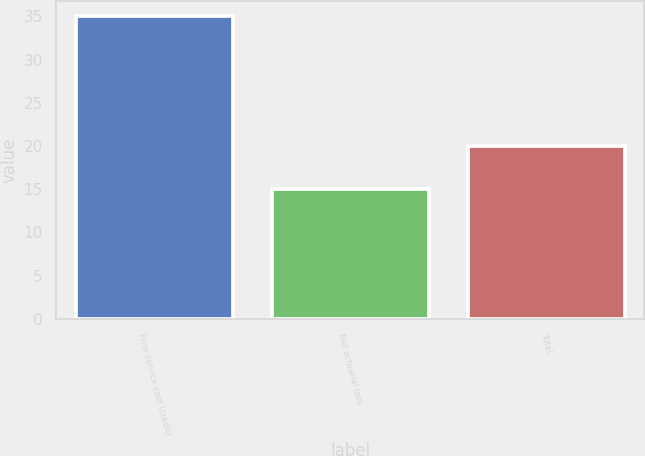Convert chart. <chart><loc_0><loc_0><loc_500><loc_500><bar_chart><fcel>Prior service cost (credit)<fcel>Net actuarial loss<fcel>Total<nl><fcel>35<fcel>15<fcel>20<nl></chart> 